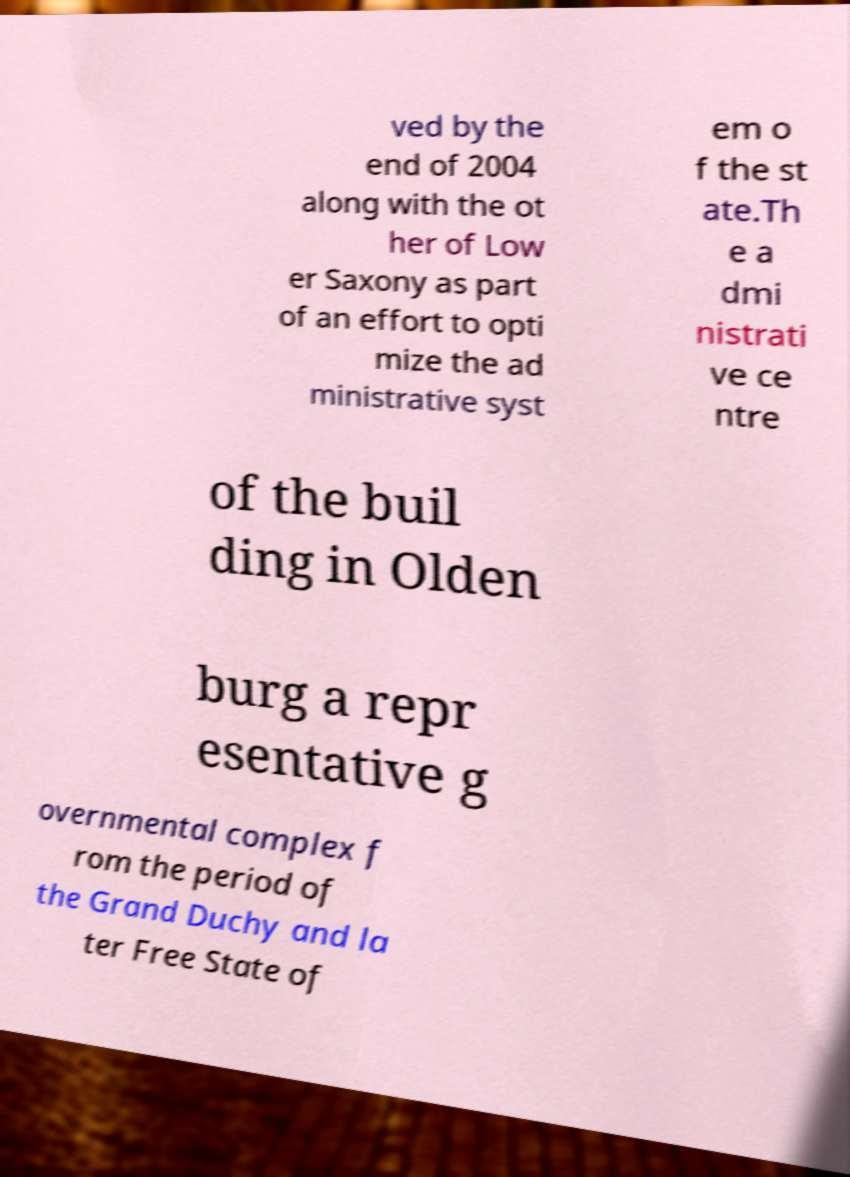What messages or text are displayed in this image? I need them in a readable, typed format. ved by the end of 2004 along with the ot her of Low er Saxony as part of an effort to opti mize the ad ministrative syst em o f the st ate.Th e a dmi nistrati ve ce ntre of the buil ding in Olden burg a repr esentative g overnmental complex f rom the period of the Grand Duchy and la ter Free State of 